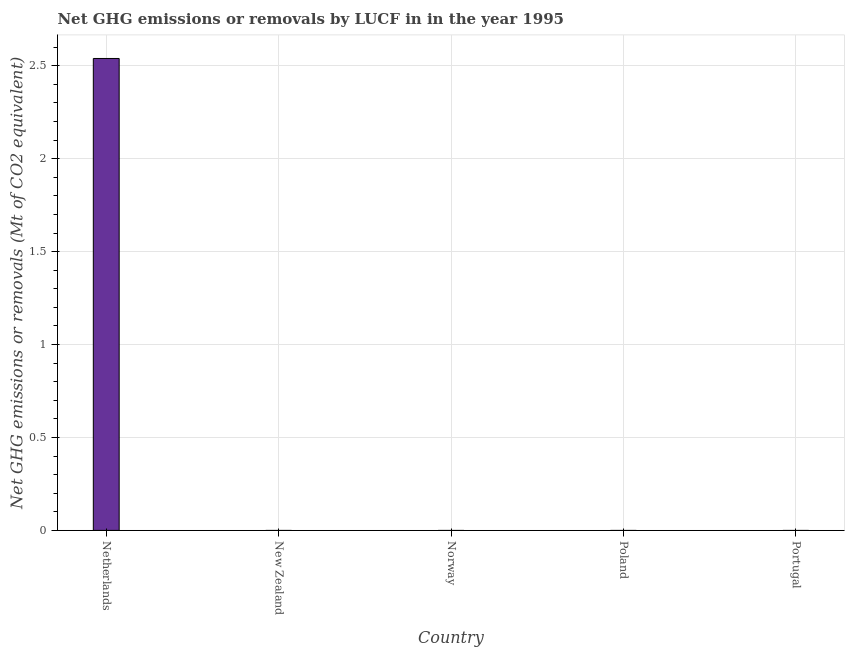What is the title of the graph?
Your answer should be very brief. Net GHG emissions or removals by LUCF in in the year 1995. What is the label or title of the X-axis?
Offer a terse response. Country. What is the label or title of the Y-axis?
Ensure brevity in your answer.  Net GHG emissions or removals (Mt of CO2 equivalent). Across all countries, what is the maximum ghg net emissions or removals?
Offer a terse response. 2.54. In which country was the ghg net emissions or removals maximum?
Provide a succinct answer. Netherlands. What is the sum of the ghg net emissions or removals?
Make the answer very short. 2.54. What is the average ghg net emissions or removals per country?
Ensure brevity in your answer.  0.51. What is the median ghg net emissions or removals?
Offer a very short reply. 0. What is the difference between the highest and the lowest ghg net emissions or removals?
Offer a terse response. 2.54. In how many countries, is the ghg net emissions or removals greater than the average ghg net emissions or removals taken over all countries?
Give a very brief answer. 1. How many bars are there?
Provide a short and direct response. 1. How many countries are there in the graph?
Provide a short and direct response. 5. What is the difference between two consecutive major ticks on the Y-axis?
Your response must be concise. 0.5. What is the Net GHG emissions or removals (Mt of CO2 equivalent) in Netherlands?
Keep it short and to the point. 2.54. What is the Net GHG emissions or removals (Mt of CO2 equivalent) in Poland?
Keep it short and to the point. 0. What is the Net GHG emissions or removals (Mt of CO2 equivalent) of Portugal?
Offer a very short reply. 0. 